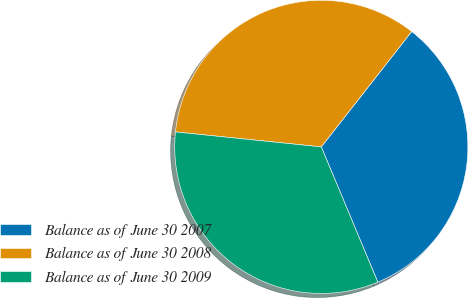Convert chart. <chart><loc_0><loc_0><loc_500><loc_500><pie_chart><fcel>Balance as of June 30 2007<fcel>Balance as of June 30 2008<fcel>Balance as of June 30 2009<nl><fcel>33.13%<fcel>33.95%<fcel>32.93%<nl></chart> 